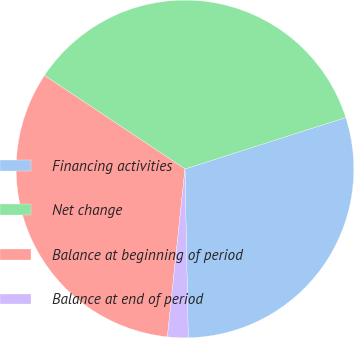Convert chart to OTSL. <chart><loc_0><loc_0><loc_500><loc_500><pie_chart><fcel>Financing activities<fcel>Net change<fcel>Balance at beginning of period<fcel>Balance at end of period<nl><fcel>29.62%<fcel>35.73%<fcel>32.68%<fcel>1.97%<nl></chart> 